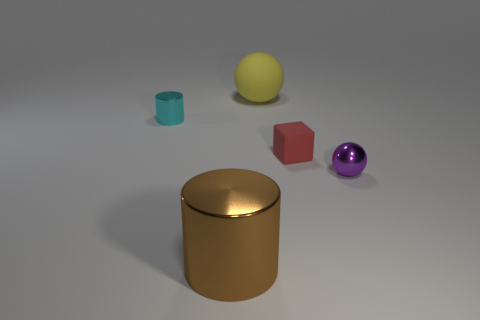Are the red thing and the brown cylinder that is left of the red matte object made of the same material? From the image, it appears that the red cube and the brown cylinder are not made of the same material. The red cube has a matte finish indicating a potentially porous or non-reflective surface, while the brown cylinder has a glossy, reflective surface that suggests it might be metallic or have a polished finish. 